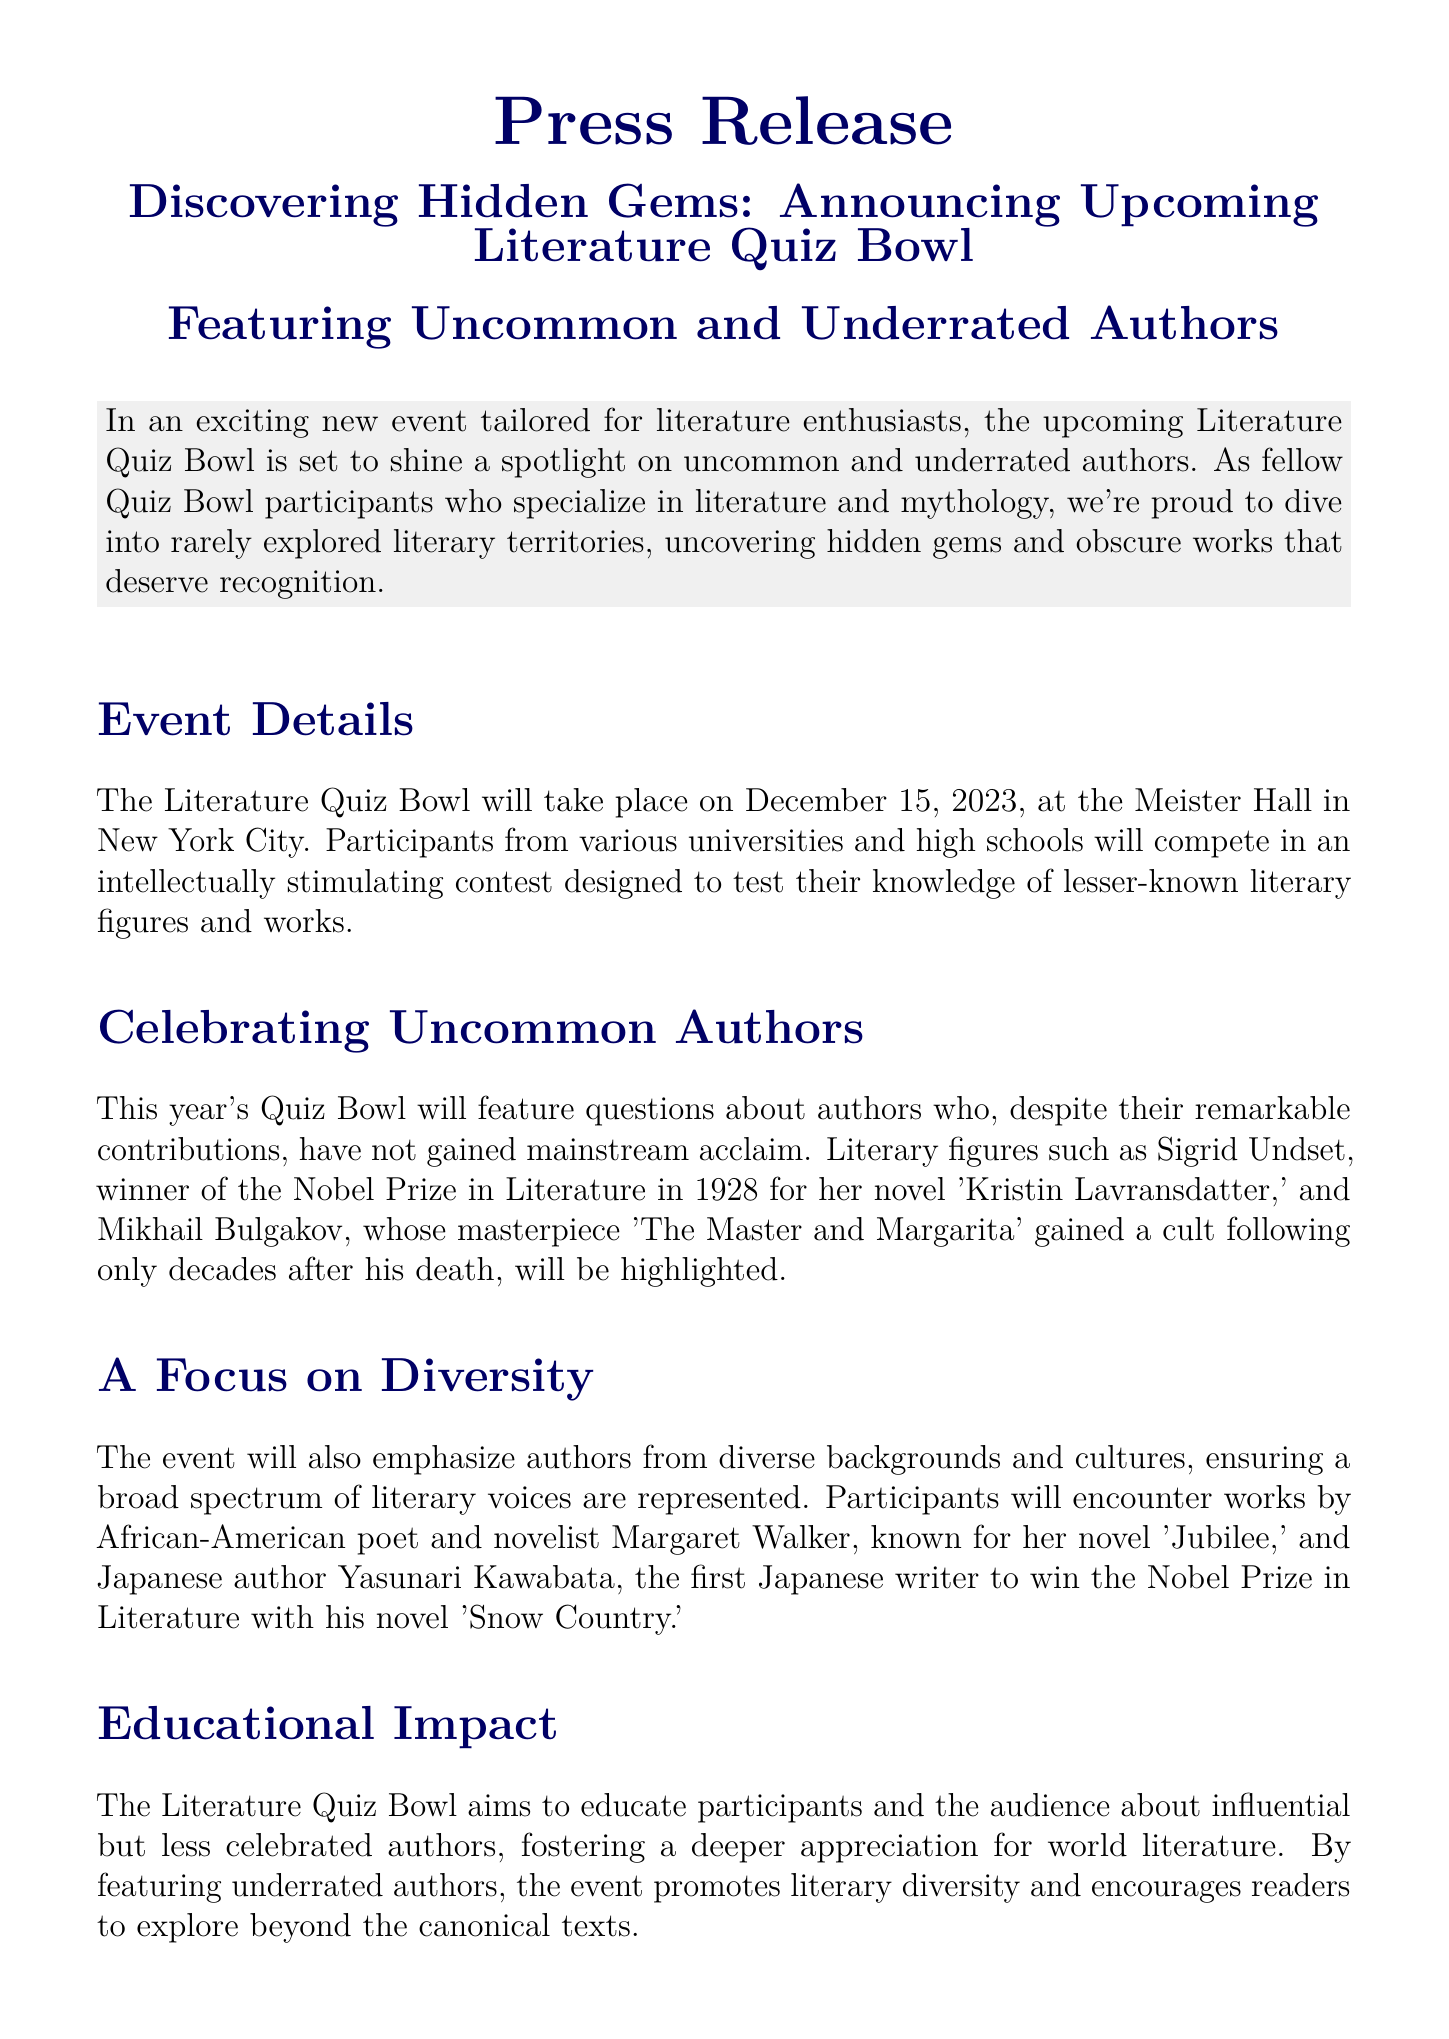What is the date of the Literature Quiz Bowl? The document states that the event will take place on December 15, 2023.
Answer: December 15, 2023 Who is one of the authors highlighted in the Quiz Bowl? The document mentions Sigrid Undset as one of the authors featured in the Quiz Bowl.
Answer: Sigrid Undset Which hall will host the Literature Quiz Bowl? The event is scheduled to take place at Meister Hall, as mentioned in the document.
Answer: Meister Hall What is the registration deadline for participants? The document specifies that registration closes on November 30, 2023.
Answer: November 30, 2023 What is the purpose of the Literature Quiz Bowl? The event aims to educate participants and the audience about influential but less celebrated authors.
Answer: To educate participants Which prize did Yasunari Kawabata win? The document states that Yasunari Kawabata was the first Japanese writer to win the Nobel Prize in Literature.
Answer: Nobel Prize in Literature Why is the Quiz Bowl focusing on underrated authors? The document indicates that it promotes literary diversity and encourages exploring beyond the canonical texts.
Answer: To promote literary diversity What types of authors will be emphasized in the event? The document mentions that the event will emphasize authors from diverse backgrounds and cultures.
Answer: Diverse backgrounds and cultures 